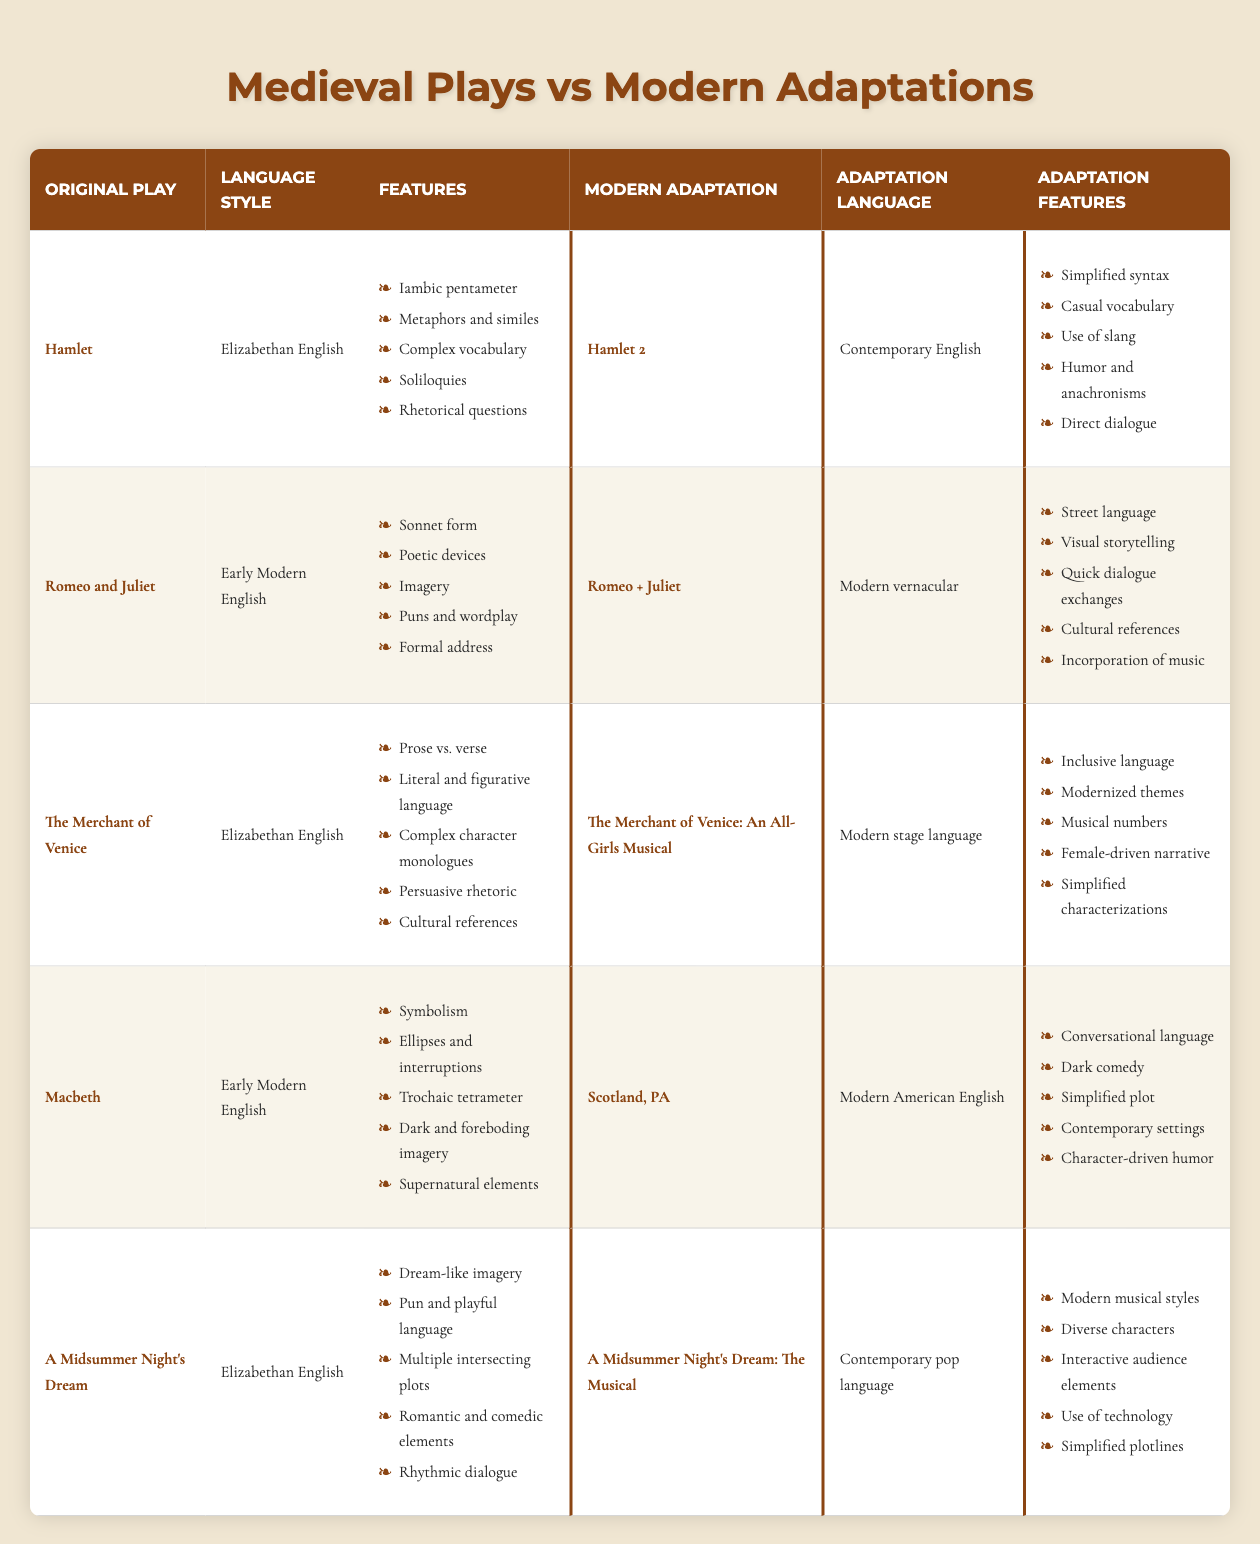What language style is used in "Hamlet"? The table lists "Hamlet" under the "Language Style" column as "Elizabethan English."
Answer: Elizabethan English Which modern adaptation of "Macbeth" uses contemporary American English? The table shows that "Scotland, PA" is the modern adaptation listed under "Macbeth," with "Modern American English" as the adaptation language.
Answer: Scotland, PA Does "Romeo + Juliet" include poetic devices in its features? The features of "Romeo + Juliet" include "Street language," "Visual storytelling," and others, but it does not mention poetic devices, which are found in the original play. Therefore, the statement is false.
Answer: No How many features are listed for "A Midsummer Night's Dream" and its modern adaptation? "A Midsummer Night's Dream" has five original features and "A Midsummer Night's Dream: The Musical" has five adaptation features, totaling ten features.
Answer: 10 Which adaptation features humor and anachronisms? The adaptation language features of "Hamlet 2" include "Humor and anachronisms."
Answer: Hamlet 2 What is the common language style shared by "Hamlet" and "The Merchant of Venice"? Both plays are categorized under "Elizabethan English" in the language style column.
Answer: Elizabethan English Compare the number of features between "Macbeth" and its adaptation. "Macbeth" has five features listed, and "Scotland, PA" also lists five features, hence they have the same number.
Answer: They have the same number of features Is inclusive language used in the modern adaptation of "The Merchant of Venice"? The adaptation features of "The Merchant of Venice: An All-Girls Musical" include "Inclusive language," confirming its presence in the adaptation.
Answer: Yes Which play has a modern adaptation that incorporates music? "Romeo + Juliet" adaptation features include "Incorporation of music," indicating music is a part of its modern version.
Answer: Romeo + Juliet Determine the difference in language styles between "Hamlet" and "Macbeth". "Hamlet" uses Elizabethan English, while "Macbeth" uses Early Modern English, representing a difference in updating time frames.
Answer: Elizabethan vs. Early Modern English 